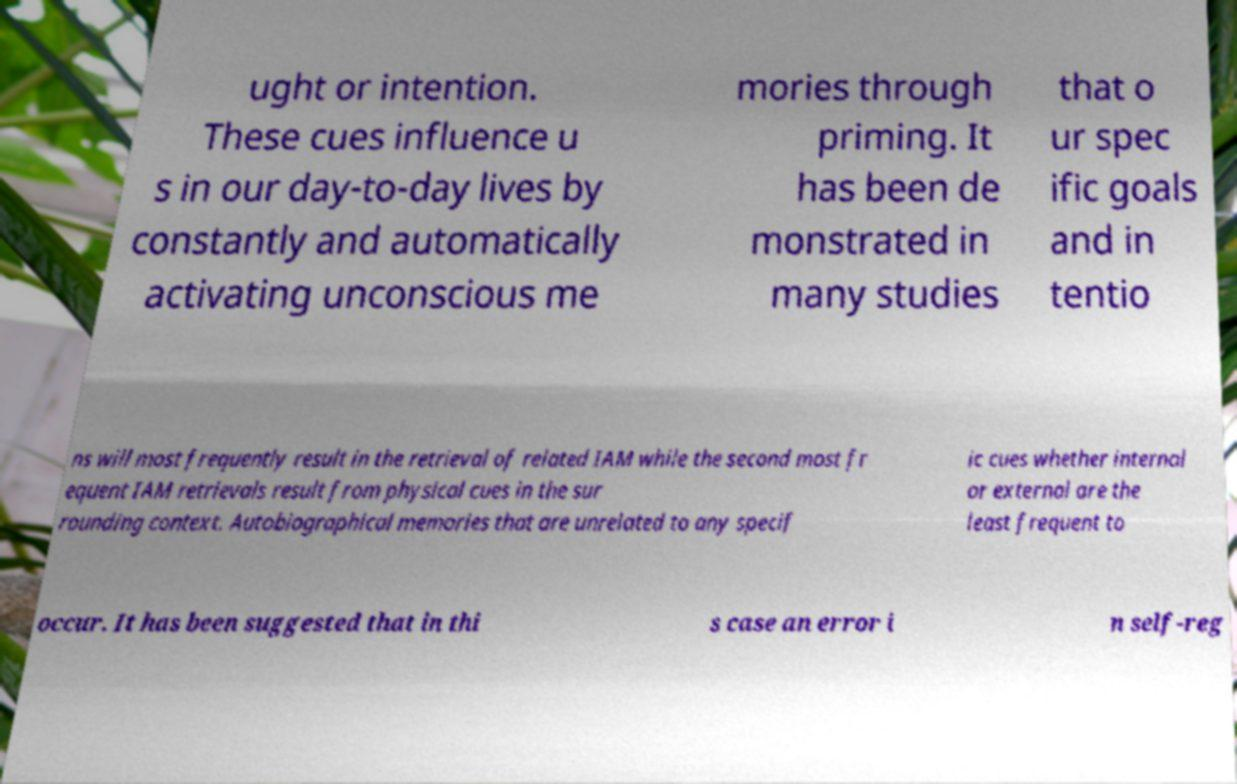For documentation purposes, I need the text within this image transcribed. Could you provide that? ught or intention. These cues influence u s in our day-to-day lives by constantly and automatically activating unconscious me mories through priming. It has been de monstrated in many studies that o ur spec ific goals and in tentio ns will most frequently result in the retrieval of related IAM while the second most fr equent IAM retrievals result from physical cues in the sur rounding context. Autobiographical memories that are unrelated to any specif ic cues whether internal or external are the least frequent to occur. It has been suggested that in thi s case an error i n self-reg 